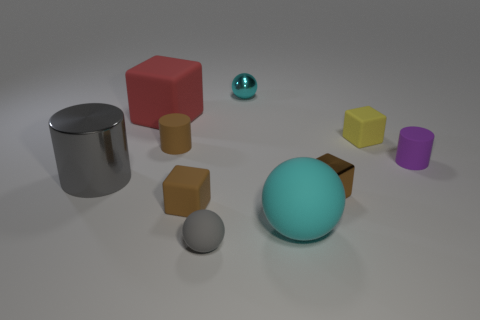Subtract all cubes. How many objects are left? 6 Subtract all cyan metallic spheres. Subtract all big matte objects. How many objects are left? 7 Add 6 matte cubes. How many matte cubes are left? 9 Add 5 cyan spheres. How many cyan spheres exist? 7 Subtract 0 cyan cylinders. How many objects are left? 10 